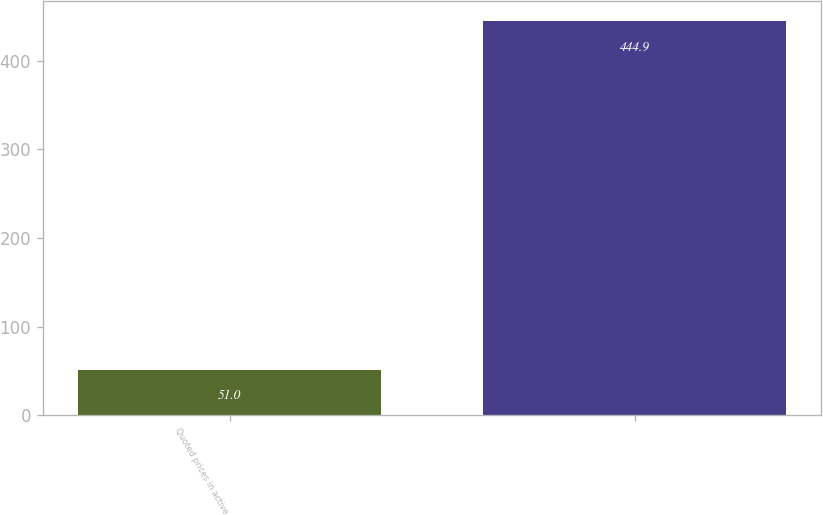Convert chart. <chart><loc_0><loc_0><loc_500><loc_500><bar_chart><fcel>Quoted prices in active<fcel>Unnamed: 1<nl><fcel>51<fcel>444.9<nl></chart> 